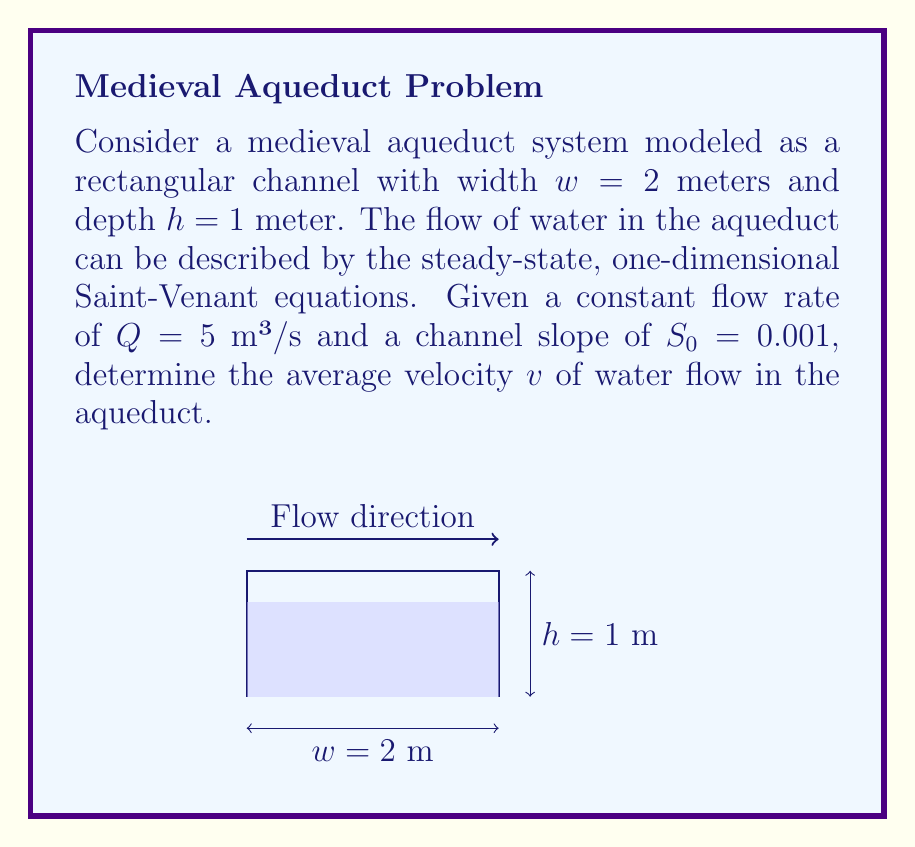Give your solution to this math problem. To solve this problem, we'll use the continuity equation from the Saint-Venant equations:

$$ Q = A \cdot v $$

Where:
- $Q$ is the flow rate (m³/s)
- $A$ is the cross-sectional area of the channel (m²)
- $v$ is the average velocity (m/s)

Steps to solve:

1) Calculate the cross-sectional area $A$:
   $$ A = w \cdot h = 2 \text{ m} \cdot 1 \text{ m} = 2 \text{ m}² $$

2) Rearrange the continuity equation to solve for $v$:
   $$ v = \frac{Q}{A} $$

3) Substitute the known values:
   $$ v = \frac{5 \text{ m}³/\text{s}}{2 \text{ m}²} $$

4) Calculate the result:
   $$ v = 2.5 \text{ m/s} $$

Note: In a more complex analysis, we would also consider the Manning's equation to relate velocity to channel slope and roughness. However, for this simplified problem, we focus solely on the continuity equation.
Answer: $2.5 \text{ m/s}$ 